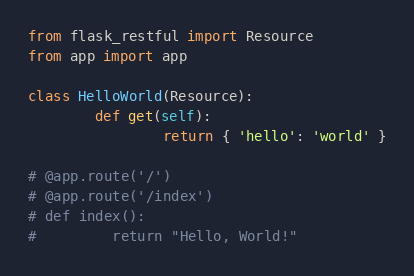<code> <loc_0><loc_0><loc_500><loc_500><_Python_>from flask_restful import Resource
from app import app

class HelloWorld(Resource):
        def get(self):
                return { 'hello': 'world' }

# @app.route('/')
# @app.route('/index')
# def index():
#         return "Hello, World!"
</code> 